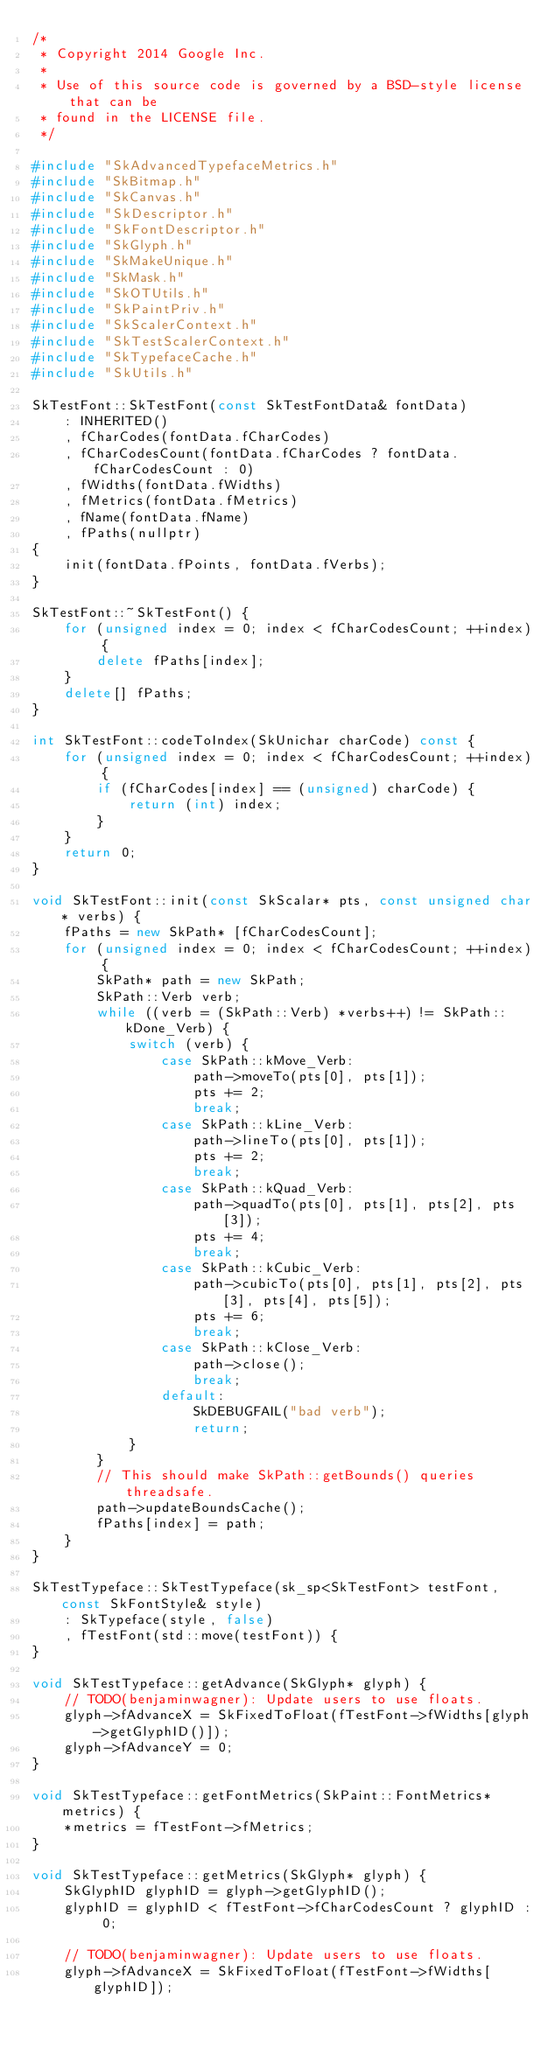<code> <loc_0><loc_0><loc_500><loc_500><_C++_>/*
 * Copyright 2014 Google Inc.
 *
 * Use of this source code is governed by a BSD-style license that can be
 * found in the LICENSE file.
 */

#include "SkAdvancedTypefaceMetrics.h"
#include "SkBitmap.h"
#include "SkCanvas.h"
#include "SkDescriptor.h"
#include "SkFontDescriptor.h"
#include "SkGlyph.h"
#include "SkMakeUnique.h"
#include "SkMask.h"
#include "SkOTUtils.h"
#include "SkPaintPriv.h"
#include "SkScalerContext.h"
#include "SkTestScalerContext.h"
#include "SkTypefaceCache.h"
#include "SkUtils.h"

SkTestFont::SkTestFont(const SkTestFontData& fontData)
    : INHERITED()
    , fCharCodes(fontData.fCharCodes)
    , fCharCodesCount(fontData.fCharCodes ? fontData.fCharCodesCount : 0)
    , fWidths(fontData.fWidths)
    , fMetrics(fontData.fMetrics)
    , fName(fontData.fName)
    , fPaths(nullptr)
{
    init(fontData.fPoints, fontData.fVerbs);
}

SkTestFont::~SkTestFont() {
    for (unsigned index = 0; index < fCharCodesCount; ++index) {
        delete fPaths[index];
    }
    delete[] fPaths;
}

int SkTestFont::codeToIndex(SkUnichar charCode) const {
    for (unsigned index = 0; index < fCharCodesCount; ++index) {
        if (fCharCodes[index] == (unsigned) charCode) {
            return (int) index;
        }
    }
    return 0;
}

void SkTestFont::init(const SkScalar* pts, const unsigned char* verbs) {
    fPaths = new SkPath* [fCharCodesCount];
    for (unsigned index = 0; index < fCharCodesCount; ++index) {
        SkPath* path = new SkPath;
        SkPath::Verb verb;
        while ((verb = (SkPath::Verb) *verbs++) != SkPath::kDone_Verb) {
            switch (verb) {
                case SkPath::kMove_Verb:
                    path->moveTo(pts[0], pts[1]);
                    pts += 2;
                    break;
                case SkPath::kLine_Verb:
                    path->lineTo(pts[0], pts[1]);
                    pts += 2;
                    break;
                case SkPath::kQuad_Verb:
                    path->quadTo(pts[0], pts[1], pts[2], pts[3]);
                    pts += 4;
                    break;
                case SkPath::kCubic_Verb:
                    path->cubicTo(pts[0], pts[1], pts[2], pts[3], pts[4], pts[5]);
                    pts += 6;
                    break;
                case SkPath::kClose_Verb:
                    path->close();
                    break;
                default:
                    SkDEBUGFAIL("bad verb");
                    return;
            }
        }
        // This should make SkPath::getBounds() queries threadsafe.
        path->updateBoundsCache();
        fPaths[index] = path;
    }
}

SkTestTypeface::SkTestTypeface(sk_sp<SkTestFont> testFont, const SkFontStyle& style)
    : SkTypeface(style, false)
    , fTestFont(std::move(testFont)) {
}

void SkTestTypeface::getAdvance(SkGlyph* glyph) {
    // TODO(benjaminwagner): Update users to use floats.
    glyph->fAdvanceX = SkFixedToFloat(fTestFont->fWidths[glyph->getGlyphID()]);
    glyph->fAdvanceY = 0;
}

void SkTestTypeface::getFontMetrics(SkPaint::FontMetrics* metrics) {
    *metrics = fTestFont->fMetrics;
}

void SkTestTypeface::getMetrics(SkGlyph* glyph) {
    SkGlyphID glyphID = glyph->getGlyphID();
    glyphID = glyphID < fTestFont->fCharCodesCount ? glyphID : 0;

    // TODO(benjaminwagner): Update users to use floats.
    glyph->fAdvanceX = SkFixedToFloat(fTestFont->fWidths[glyphID]);</code> 